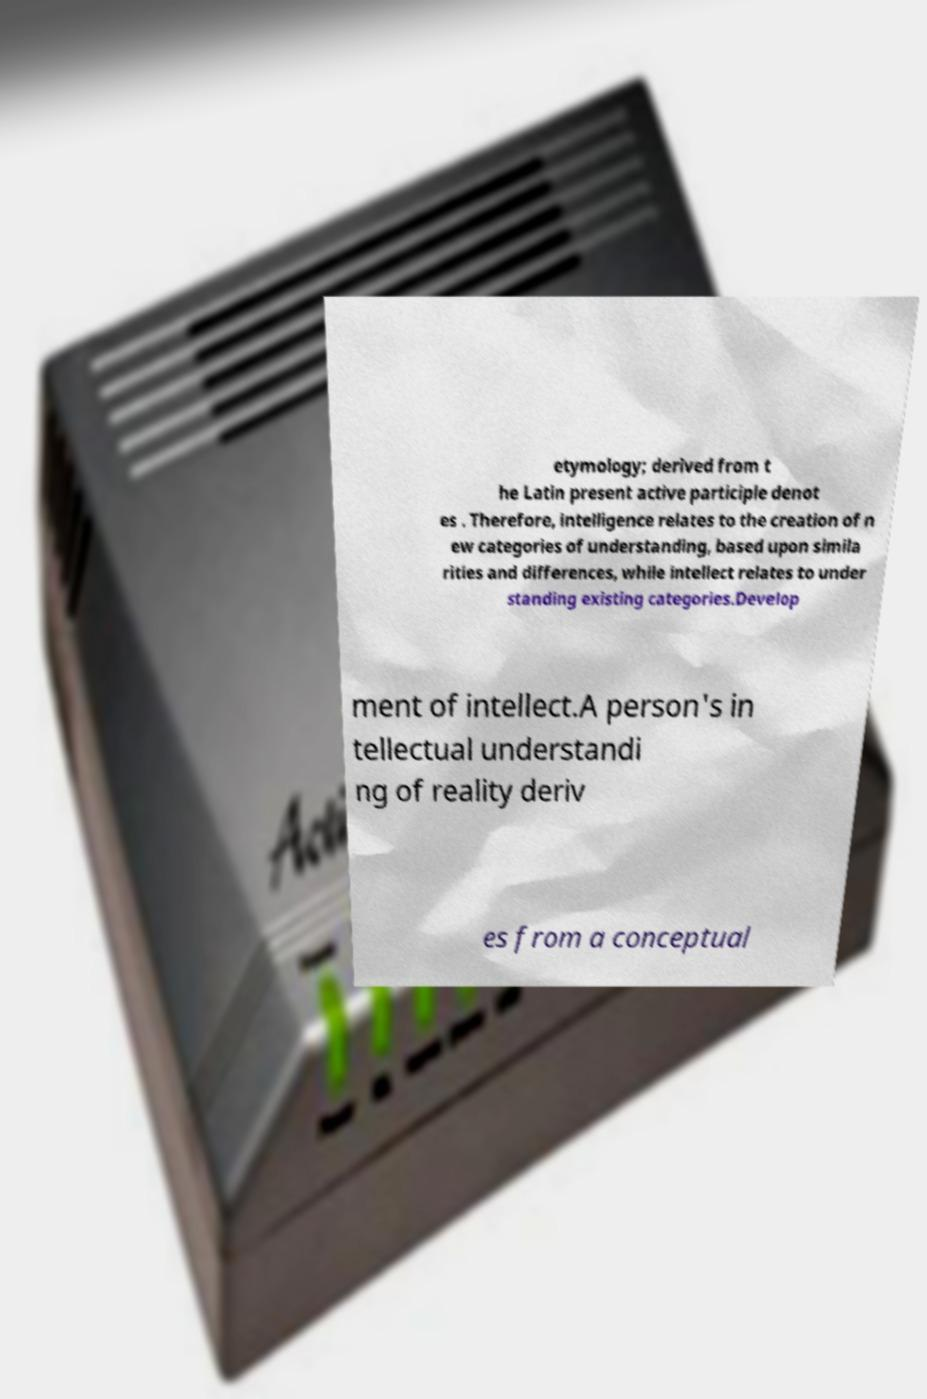For documentation purposes, I need the text within this image transcribed. Could you provide that? etymology; derived from t he Latin present active participle denot es . Therefore, intelligence relates to the creation of n ew categories of understanding, based upon simila rities and differences, while intellect relates to under standing existing categories.Develop ment of intellect.A person's in tellectual understandi ng of reality deriv es from a conceptual 